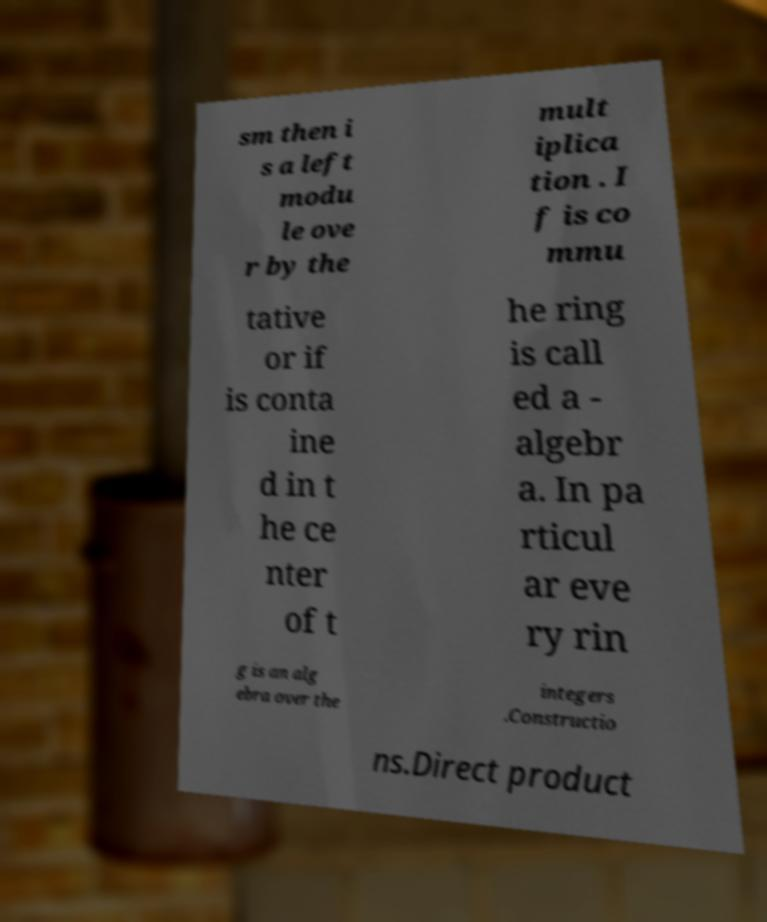Please identify and transcribe the text found in this image. sm then i s a left modu le ove r by the mult iplica tion . I f is co mmu tative or if is conta ine d in t he ce nter of t he ring is call ed a - algebr a. In pa rticul ar eve ry rin g is an alg ebra over the integers .Constructio ns.Direct product 